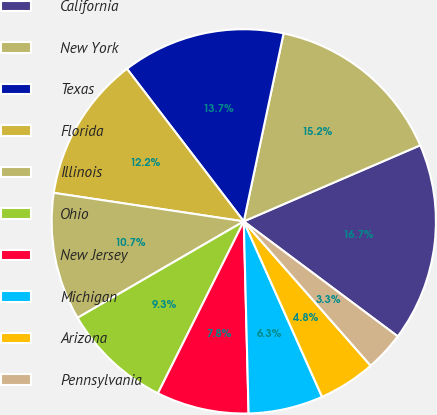Convert chart. <chart><loc_0><loc_0><loc_500><loc_500><pie_chart><fcel>California<fcel>New York<fcel>Texas<fcel>Florida<fcel>Illinois<fcel>Ohio<fcel>New Jersey<fcel>Michigan<fcel>Arizona<fcel>Pennsylvania<nl><fcel>16.69%<fcel>15.2%<fcel>13.72%<fcel>12.23%<fcel>10.74%<fcel>9.26%<fcel>7.77%<fcel>6.28%<fcel>4.8%<fcel>3.31%<nl></chart> 